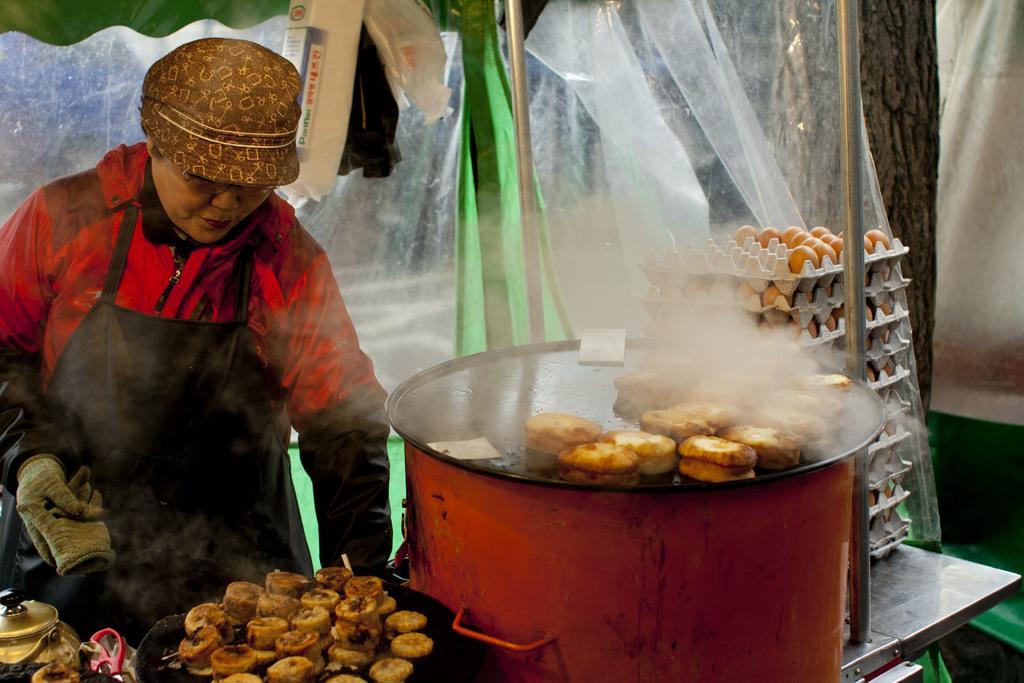In one or two sentences, can you explain what this image depicts? In this image, we can see a person. We can see a table with some objects like food items on a pan and on the top of a container. We can also see the egg trays. We can see some poles. We can see some colors and objects. 